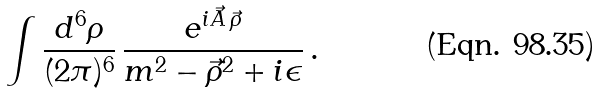Convert formula to latex. <formula><loc_0><loc_0><loc_500><loc_500>\int \frac { d ^ { 6 } \rho } { ( 2 \pi ) ^ { 6 } } \, \frac { e ^ { i \vec { A } \, \vec { \rho } } } { m ^ { 2 } - \vec { \rho } ^ { 2 } + i \epsilon } \, .</formula> 